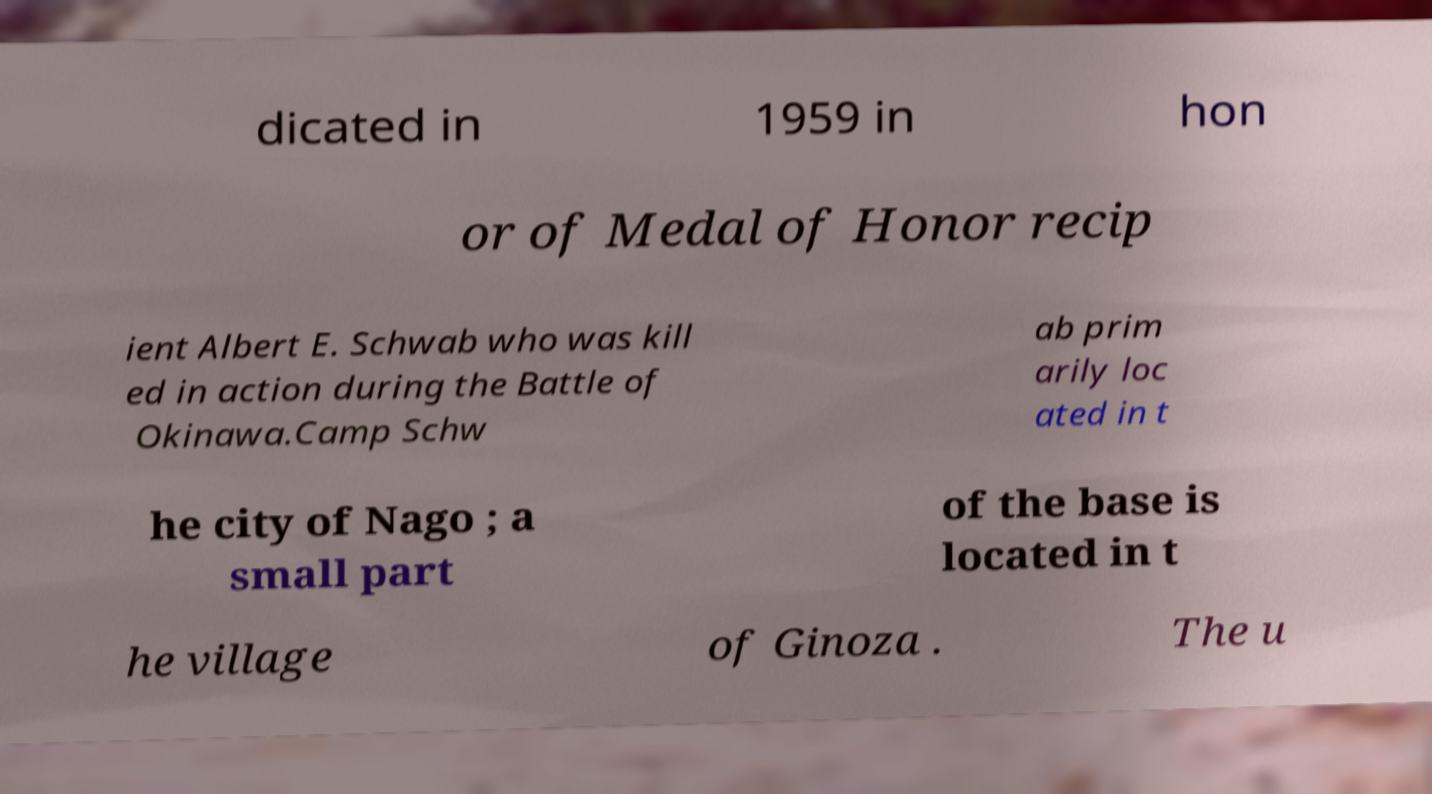Could you extract and type out the text from this image? dicated in 1959 in hon or of Medal of Honor recip ient Albert E. Schwab who was kill ed in action during the Battle of Okinawa.Camp Schw ab prim arily loc ated in t he city of Nago ; a small part of the base is located in t he village of Ginoza . The u 